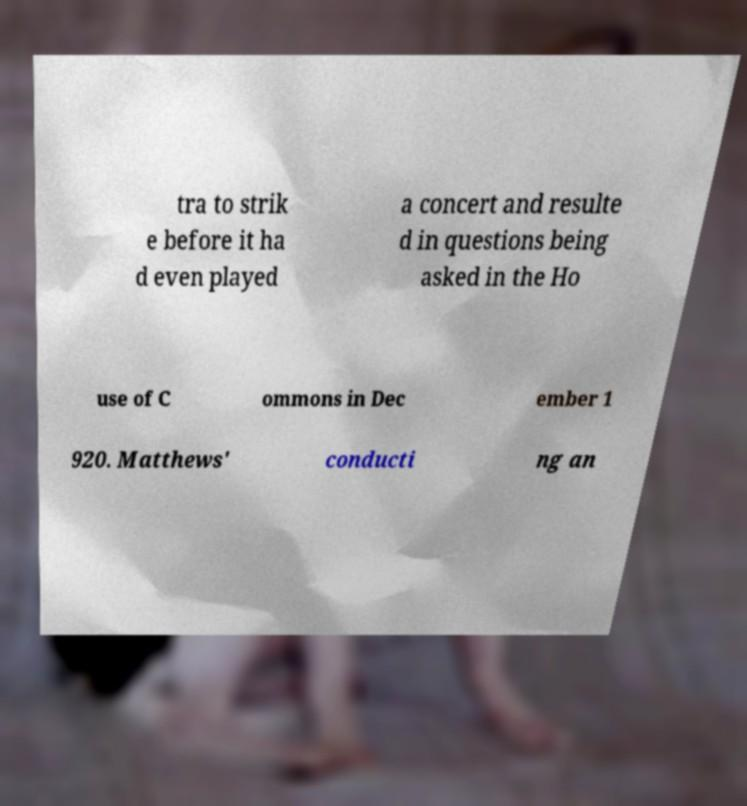Please read and relay the text visible in this image. What does it say? tra to strik e before it ha d even played a concert and resulte d in questions being asked in the Ho use of C ommons in Dec ember 1 920. Matthews' conducti ng an 